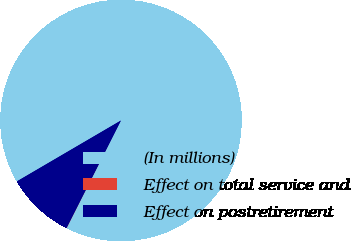<chart> <loc_0><loc_0><loc_500><loc_500><pie_chart><fcel>(In millions)<fcel>Effect on total service and<fcel>Effect on postretirement<nl><fcel>90.85%<fcel>0.03%<fcel>9.11%<nl></chart> 